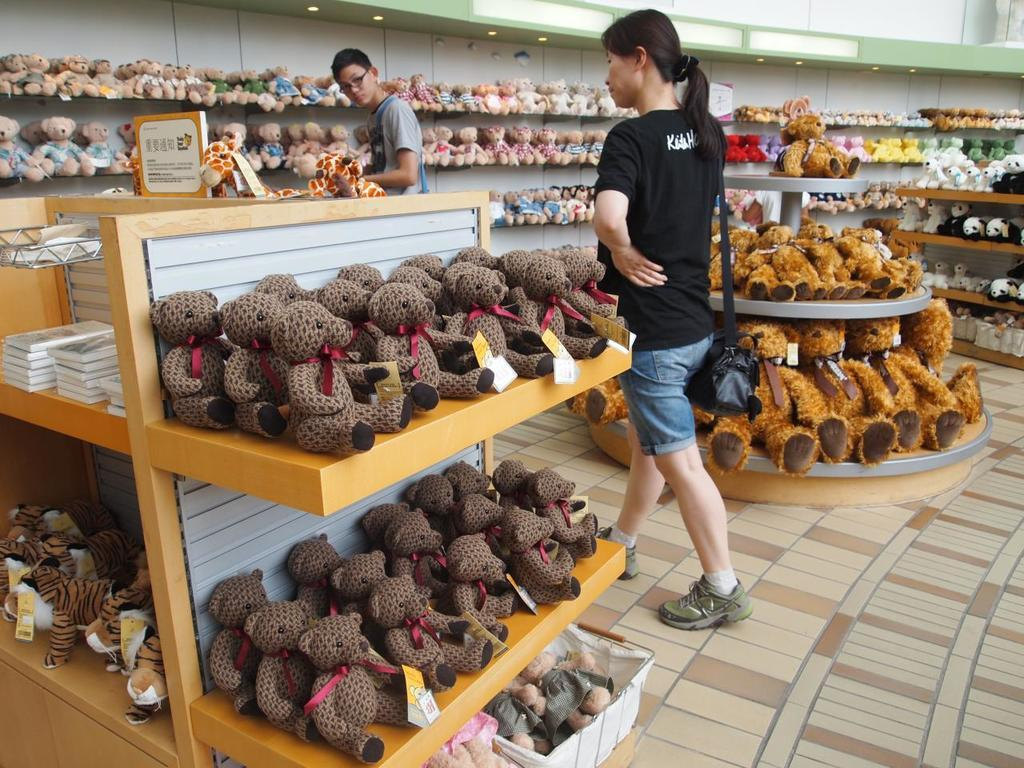Where was the image taken? The image was taken inside a store. What can be seen in the center of the image? There are people in the center of the image. What type of products are displayed on the shelves? There are soft toys placed on shelves. What can be seen illuminating the store? There are lights visible in the image. What type of plantation can be seen in the image? There is no plantation present in the image; it was taken inside a store. What is the value of the jar in the image? There is no jar present in the image. 